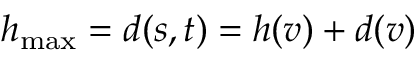<formula> <loc_0><loc_0><loc_500><loc_500>h _ { \max } = d ( s , t ) = h ( v ) + d ( v )</formula> 